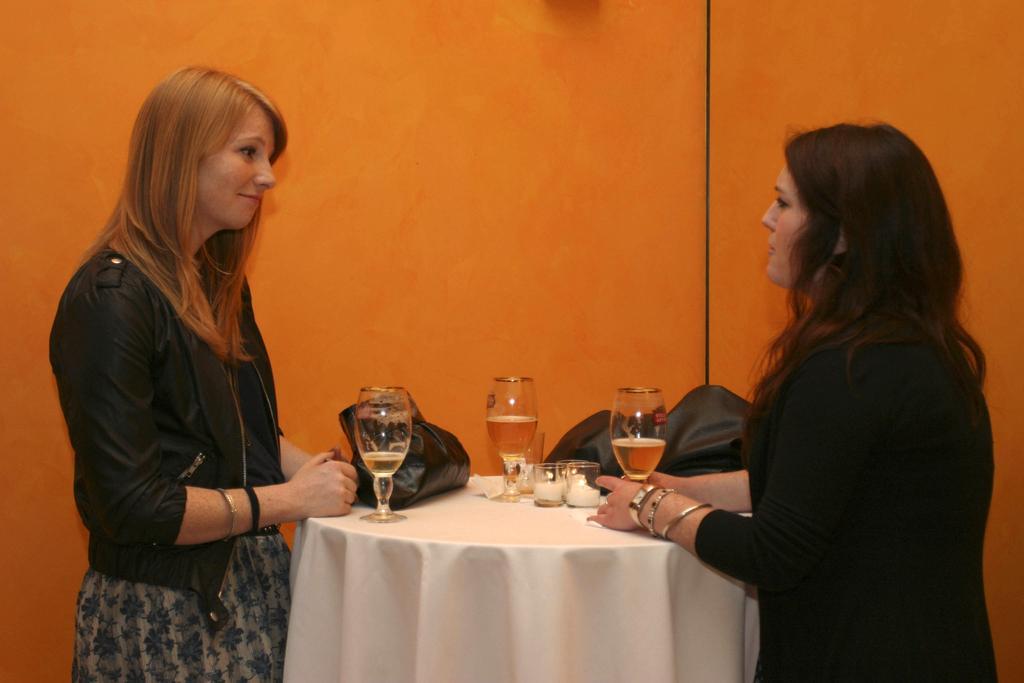Can you describe this image briefly? 2 people are standing in front of a table. on the table there is are bags, glass and candles. 